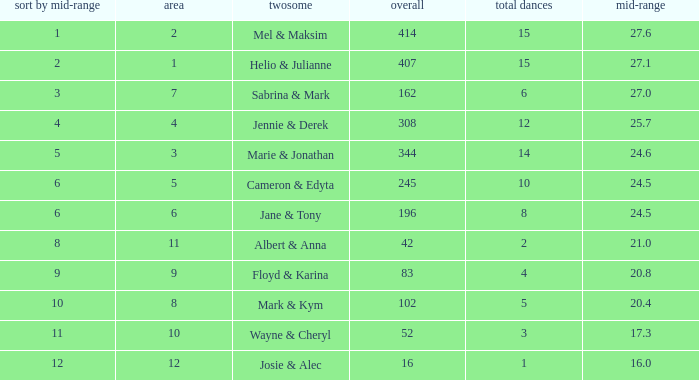What is the smallest place number when the total is 16 and average is less than 16? None. 